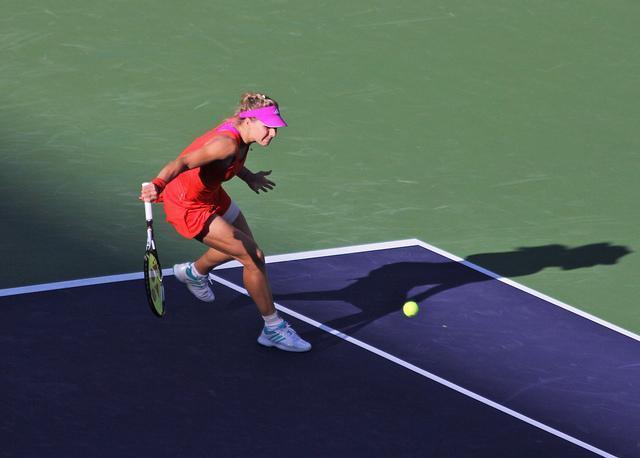How many sinks are in the bathroom?
Give a very brief answer. 0. 